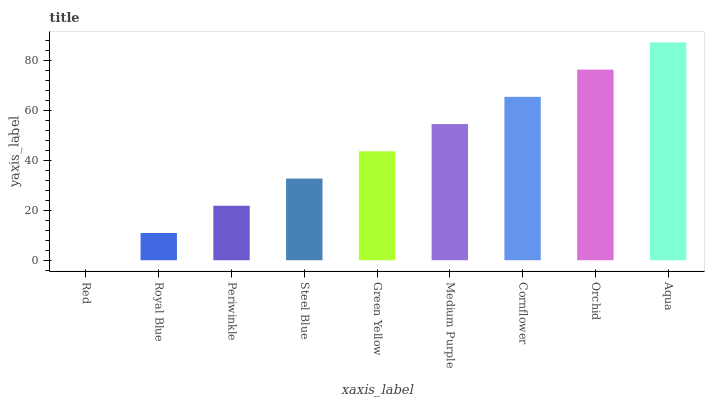Is Red the minimum?
Answer yes or no. Yes. Is Aqua the maximum?
Answer yes or no. Yes. Is Royal Blue the minimum?
Answer yes or no. No. Is Royal Blue the maximum?
Answer yes or no. No. Is Royal Blue greater than Red?
Answer yes or no. Yes. Is Red less than Royal Blue?
Answer yes or no. Yes. Is Red greater than Royal Blue?
Answer yes or no. No. Is Royal Blue less than Red?
Answer yes or no. No. Is Green Yellow the high median?
Answer yes or no. Yes. Is Green Yellow the low median?
Answer yes or no. Yes. Is Steel Blue the high median?
Answer yes or no. No. Is Royal Blue the low median?
Answer yes or no. No. 